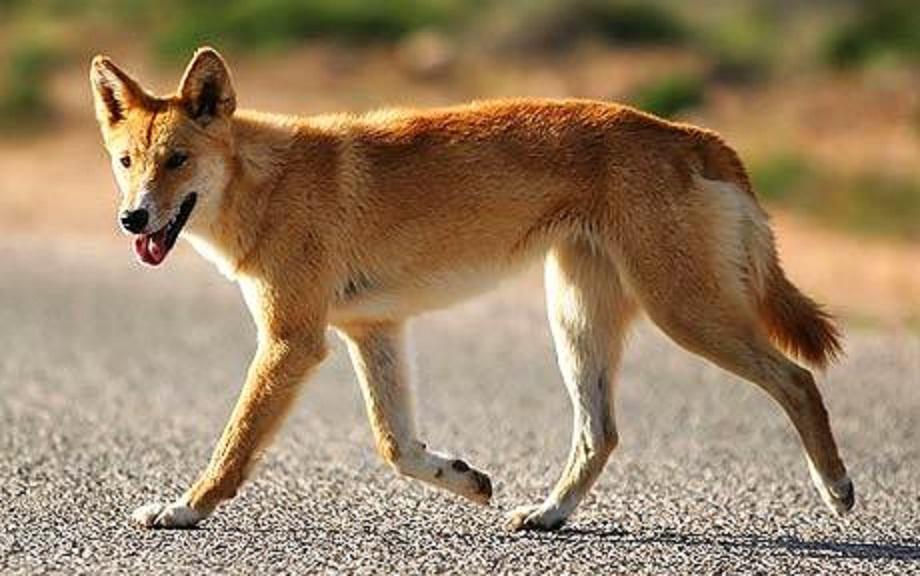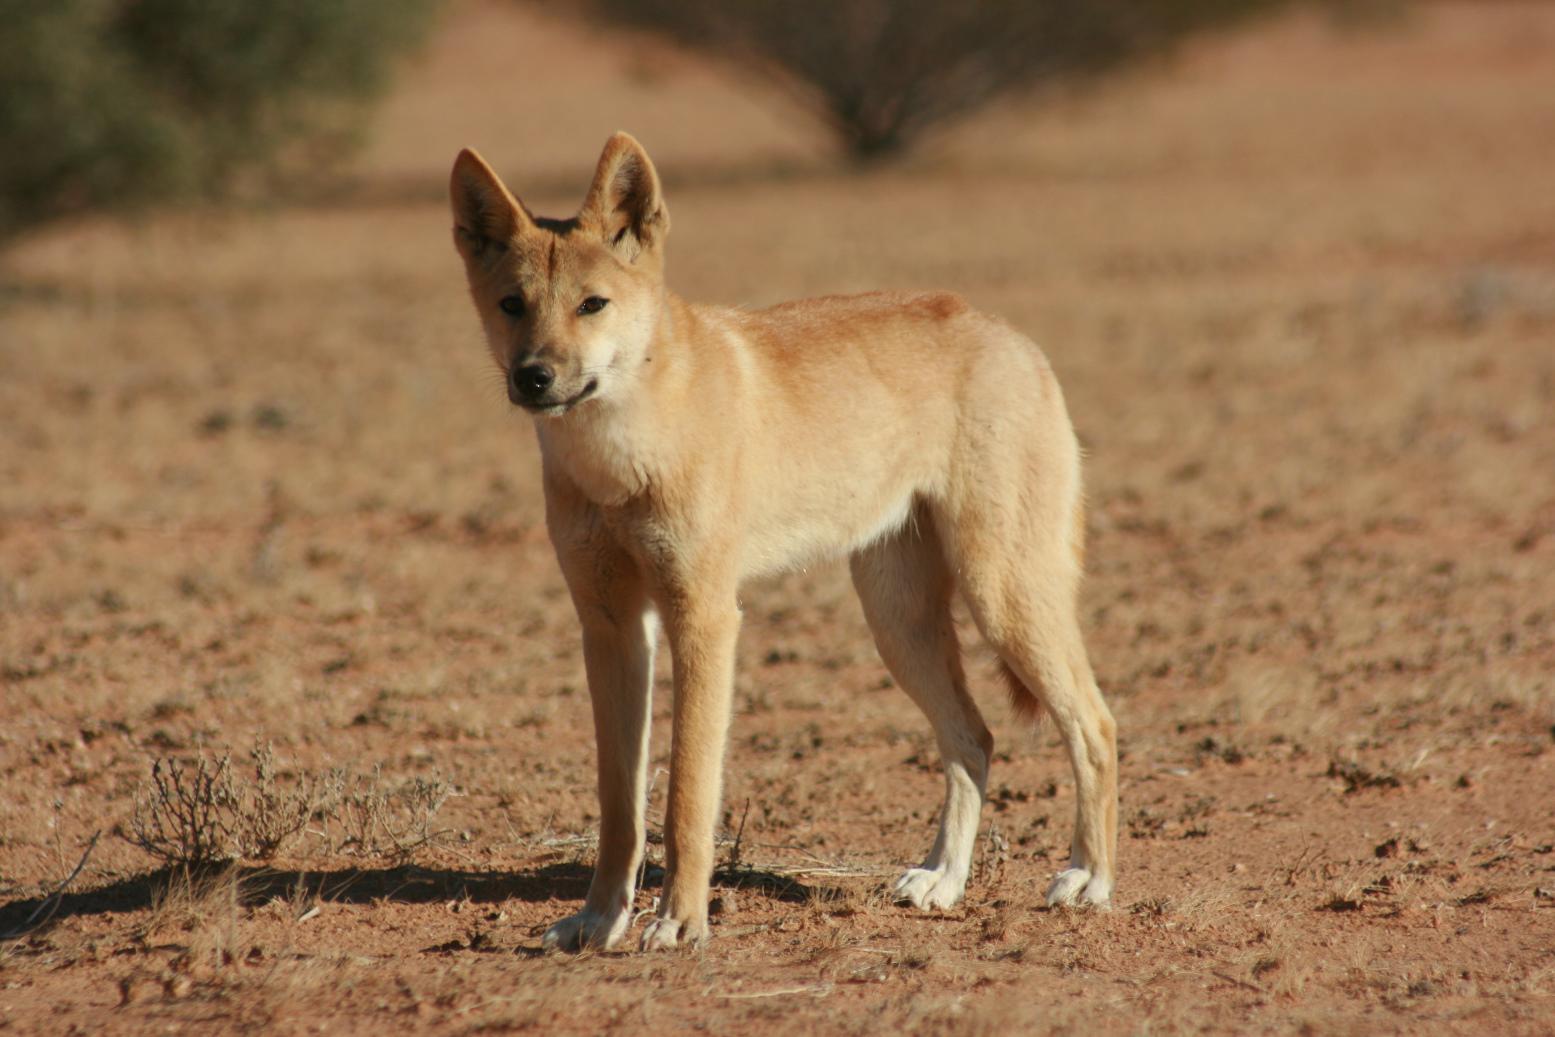The first image is the image on the left, the second image is the image on the right. Evaluate the accuracy of this statement regarding the images: "There are two dogs". Is it true? Answer yes or no. Yes. The first image is the image on the left, the second image is the image on the right. Assess this claim about the two images: "There are three dogs". Correct or not? Answer yes or no. No. 